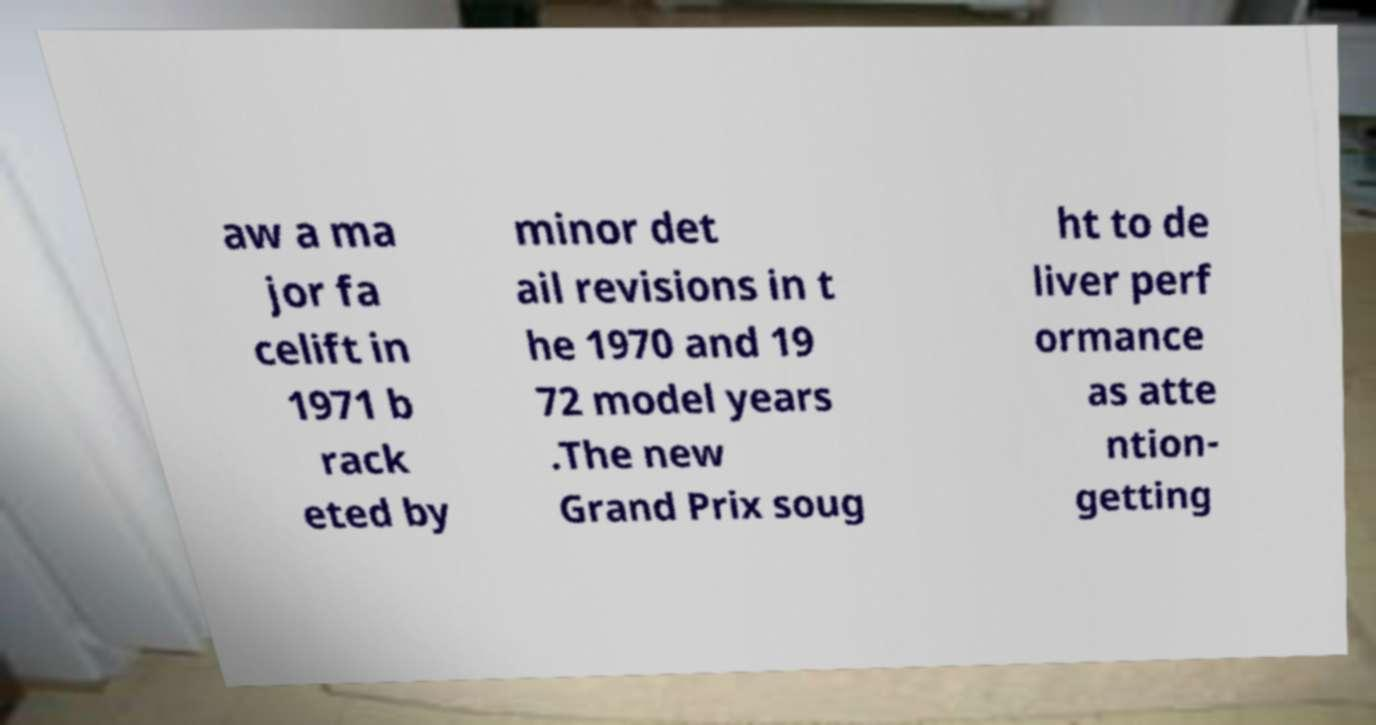There's text embedded in this image that I need extracted. Can you transcribe it verbatim? aw a ma jor fa celift in 1971 b rack eted by minor det ail revisions in t he 1970 and 19 72 model years .The new Grand Prix soug ht to de liver perf ormance as atte ntion- getting 